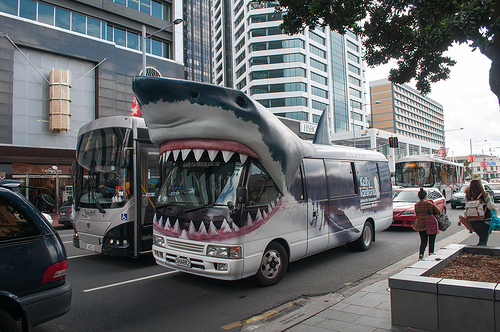<image>
Is there a bus in the shark? Yes. The bus is contained within or inside the shark, showing a containment relationship. 